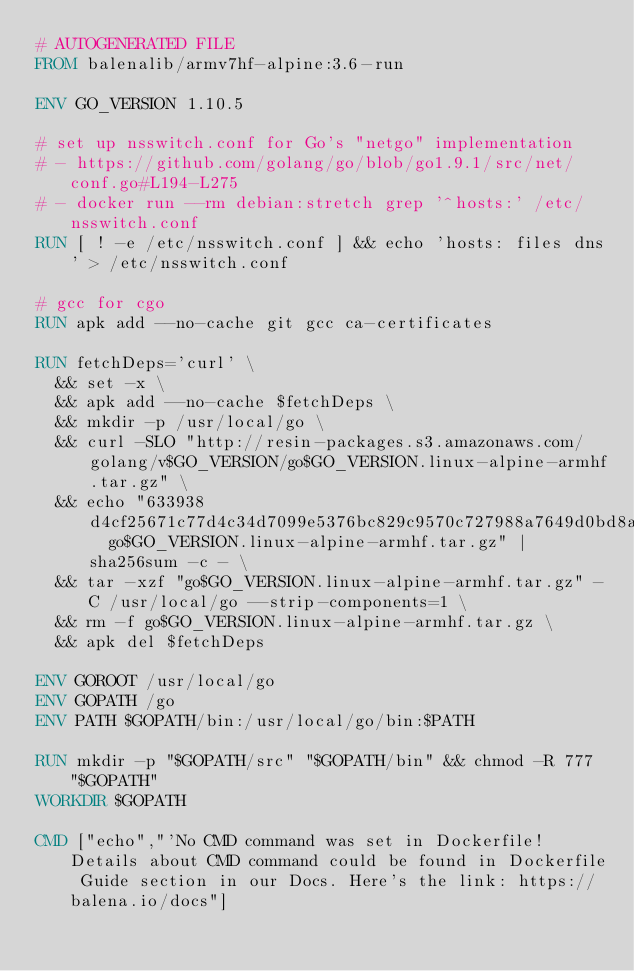Convert code to text. <code><loc_0><loc_0><loc_500><loc_500><_Dockerfile_># AUTOGENERATED FILE
FROM balenalib/armv7hf-alpine:3.6-run

ENV GO_VERSION 1.10.5

# set up nsswitch.conf for Go's "netgo" implementation
# - https://github.com/golang/go/blob/go1.9.1/src/net/conf.go#L194-L275
# - docker run --rm debian:stretch grep '^hosts:' /etc/nsswitch.conf
RUN [ ! -e /etc/nsswitch.conf ] && echo 'hosts: files dns' > /etc/nsswitch.conf

# gcc for cgo
RUN apk add --no-cache git gcc ca-certificates

RUN fetchDeps='curl' \
	&& set -x \
	&& apk add --no-cache $fetchDeps \
	&& mkdir -p /usr/local/go \
	&& curl -SLO "http://resin-packages.s3.amazonaws.com/golang/v$GO_VERSION/go$GO_VERSION.linux-alpine-armhf.tar.gz" \
	&& echo "633938d4cf25671c77d4c34d7099e5376bc829c9570c727988a7649d0bd8a48c  go$GO_VERSION.linux-alpine-armhf.tar.gz" | sha256sum -c - \
	&& tar -xzf "go$GO_VERSION.linux-alpine-armhf.tar.gz" -C /usr/local/go --strip-components=1 \
	&& rm -f go$GO_VERSION.linux-alpine-armhf.tar.gz \
	&& apk del $fetchDeps

ENV GOROOT /usr/local/go
ENV GOPATH /go
ENV PATH $GOPATH/bin:/usr/local/go/bin:$PATH

RUN mkdir -p "$GOPATH/src" "$GOPATH/bin" && chmod -R 777 "$GOPATH"
WORKDIR $GOPATH

CMD ["echo","'No CMD command was set in Dockerfile! Details about CMD command could be found in Dockerfile Guide section in our Docs. Here's the link: https://balena.io/docs"]</code> 